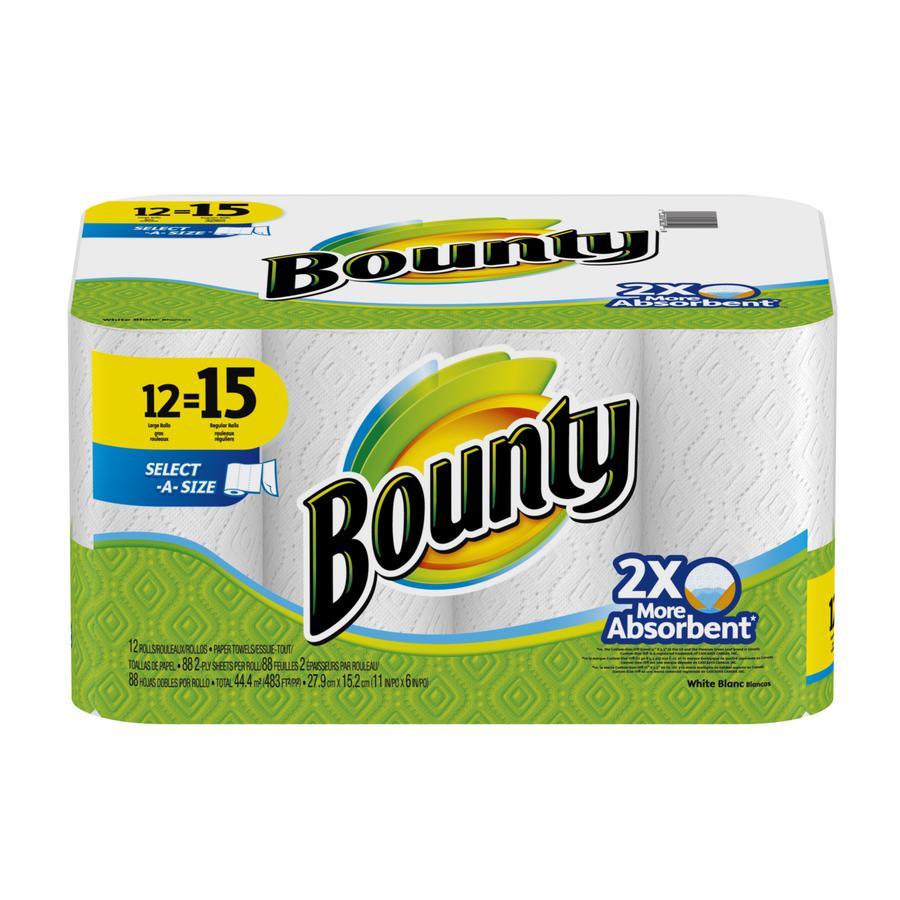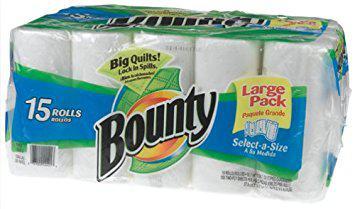The first image is the image on the left, the second image is the image on the right. For the images displayed, is the sentence "There is a package that contains larger than regular sized paper towel rolls." factually correct? Answer yes or no. Yes. The first image is the image on the left, the second image is the image on the right. Evaluate the accuracy of this statement regarding the images: "The left image shows one multi-roll package of towels with a yellow quarter circle in the upper left corner, and the package on the right features the same basic color scheme as the pack on the left.". Is it true? Answer yes or no. No. 